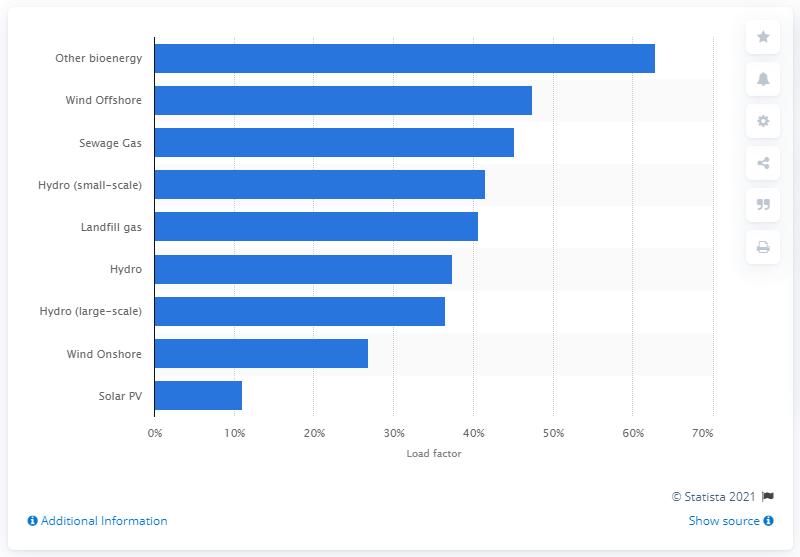Identify some key points in this picture. According to data for 2019, Scotland's load factor was 62.9%. 